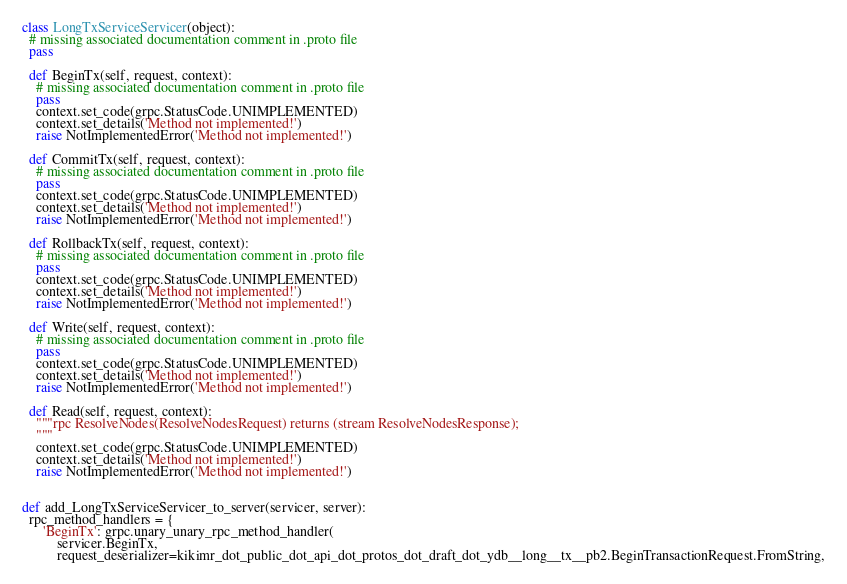Convert code to text. <code><loc_0><loc_0><loc_500><loc_500><_Python_>

class LongTxServiceServicer(object):
  # missing associated documentation comment in .proto file
  pass

  def BeginTx(self, request, context):
    # missing associated documentation comment in .proto file
    pass
    context.set_code(grpc.StatusCode.UNIMPLEMENTED)
    context.set_details('Method not implemented!')
    raise NotImplementedError('Method not implemented!')

  def CommitTx(self, request, context):
    # missing associated documentation comment in .proto file
    pass
    context.set_code(grpc.StatusCode.UNIMPLEMENTED)
    context.set_details('Method not implemented!')
    raise NotImplementedError('Method not implemented!')

  def RollbackTx(self, request, context):
    # missing associated documentation comment in .proto file
    pass
    context.set_code(grpc.StatusCode.UNIMPLEMENTED)
    context.set_details('Method not implemented!')
    raise NotImplementedError('Method not implemented!')

  def Write(self, request, context):
    # missing associated documentation comment in .proto file
    pass
    context.set_code(grpc.StatusCode.UNIMPLEMENTED)
    context.set_details('Method not implemented!')
    raise NotImplementedError('Method not implemented!')

  def Read(self, request, context):
    """rpc ResolveNodes(ResolveNodesRequest) returns (stream ResolveNodesResponse);
    """
    context.set_code(grpc.StatusCode.UNIMPLEMENTED)
    context.set_details('Method not implemented!')
    raise NotImplementedError('Method not implemented!')


def add_LongTxServiceServicer_to_server(servicer, server):
  rpc_method_handlers = {
      'BeginTx': grpc.unary_unary_rpc_method_handler(
          servicer.BeginTx,
          request_deserializer=kikimr_dot_public_dot_api_dot_protos_dot_draft_dot_ydb__long__tx__pb2.BeginTransactionRequest.FromString,</code> 